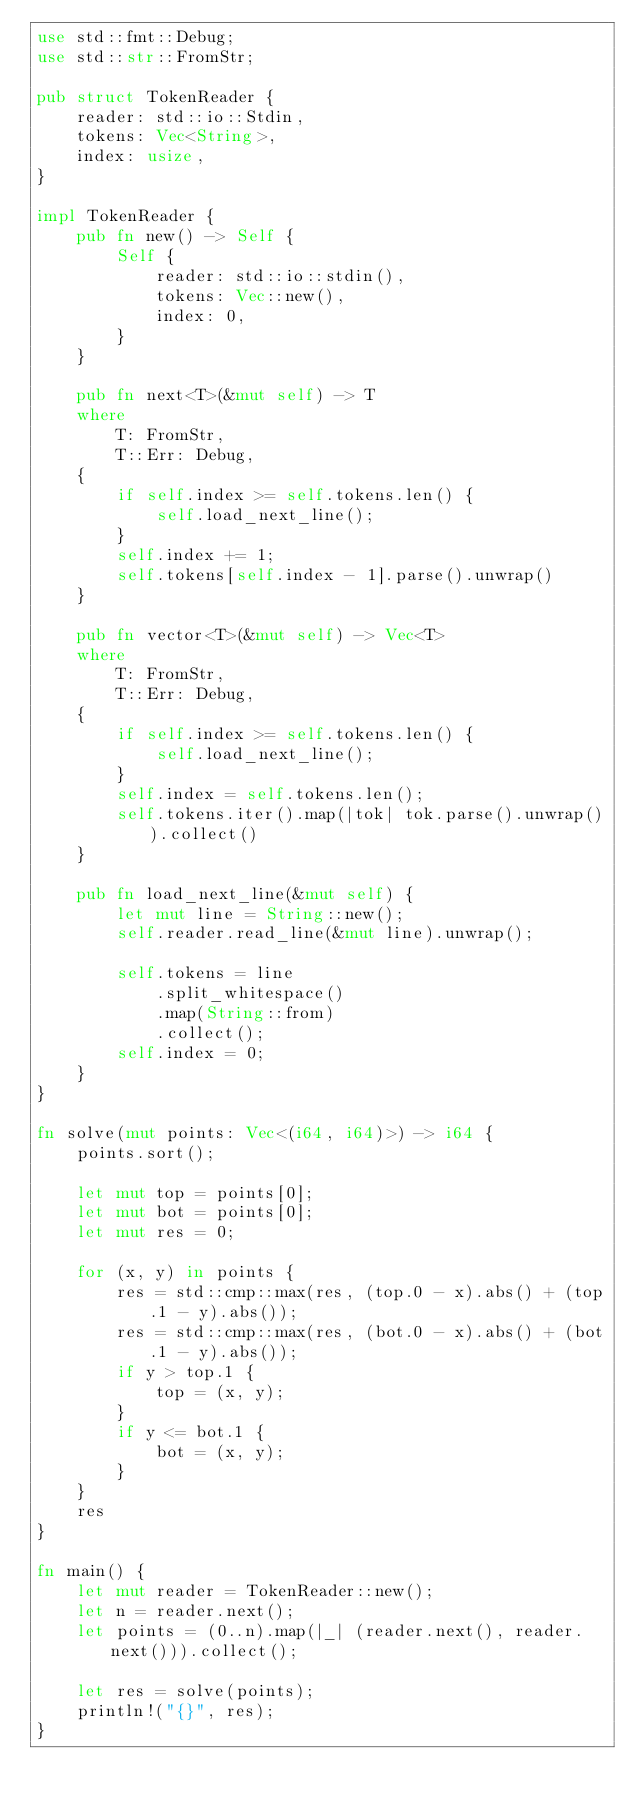Convert code to text. <code><loc_0><loc_0><loc_500><loc_500><_Rust_>use std::fmt::Debug;
use std::str::FromStr;

pub struct TokenReader {
    reader: std::io::Stdin,
    tokens: Vec<String>,
    index: usize,
}

impl TokenReader {
    pub fn new() -> Self {
        Self {
            reader: std::io::stdin(),
            tokens: Vec::new(),
            index: 0,
        }
    }

    pub fn next<T>(&mut self) -> T
    where
        T: FromStr,
        T::Err: Debug,
    {
        if self.index >= self.tokens.len() {
            self.load_next_line();
        }
        self.index += 1;
        self.tokens[self.index - 1].parse().unwrap()
    }

    pub fn vector<T>(&mut self) -> Vec<T>
    where
        T: FromStr,
        T::Err: Debug,
    {
        if self.index >= self.tokens.len() {
            self.load_next_line();
        }
        self.index = self.tokens.len();
        self.tokens.iter().map(|tok| tok.parse().unwrap()).collect()
    }

    pub fn load_next_line(&mut self) {
        let mut line = String::new();
        self.reader.read_line(&mut line).unwrap();

        self.tokens = line
            .split_whitespace()
            .map(String::from)
            .collect();
        self.index = 0;
    }
}

fn solve(mut points: Vec<(i64, i64)>) -> i64 {
    points.sort();

    let mut top = points[0];
    let mut bot = points[0];
    let mut res = 0;

    for (x, y) in points {
        res = std::cmp::max(res, (top.0 - x).abs() + (top.1 - y).abs());
        res = std::cmp::max(res, (bot.0 - x).abs() + (bot.1 - y).abs());
        if y > top.1 {
            top = (x, y);
        }
        if y <= bot.1 {
            bot = (x, y);
        }
    }
    res
}

fn main() {
    let mut reader = TokenReader::new();
    let n = reader.next();
    let points = (0..n).map(|_| (reader.next(), reader.next())).collect();

    let res = solve(points);
    println!("{}", res);
}
</code> 